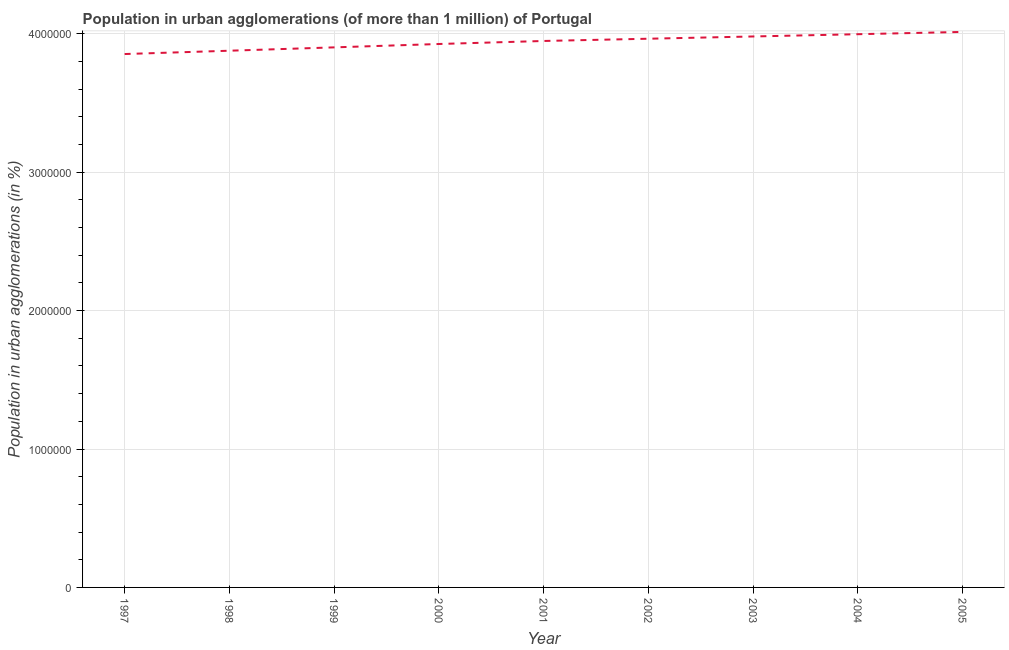What is the population in urban agglomerations in 1997?
Your response must be concise. 3.85e+06. Across all years, what is the maximum population in urban agglomerations?
Make the answer very short. 4.01e+06. Across all years, what is the minimum population in urban agglomerations?
Your answer should be very brief. 3.85e+06. What is the sum of the population in urban agglomerations?
Offer a terse response. 3.55e+07. What is the difference between the population in urban agglomerations in 2000 and 2001?
Offer a terse response. -2.19e+04. What is the average population in urban agglomerations per year?
Ensure brevity in your answer.  3.94e+06. What is the median population in urban agglomerations?
Offer a terse response. 3.95e+06. What is the ratio of the population in urban agglomerations in 2001 to that in 2003?
Give a very brief answer. 0.99. Is the difference between the population in urban agglomerations in 1997 and 2000 greater than the difference between any two years?
Give a very brief answer. No. What is the difference between the highest and the second highest population in urban agglomerations?
Provide a short and direct response. 1.64e+04. What is the difference between the highest and the lowest population in urban agglomerations?
Offer a terse response. 1.60e+05. In how many years, is the population in urban agglomerations greater than the average population in urban agglomerations taken over all years?
Provide a succinct answer. 5. Does the population in urban agglomerations monotonically increase over the years?
Your answer should be compact. Yes. How many years are there in the graph?
Ensure brevity in your answer.  9. Are the values on the major ticks of Y-axis written in scientific E-notation?
Provide a short and direct response. No. Does the graph contain any zero values?
Provide a short and direct response. No. Does the graph contain grids?
Offer a very short reply. Yes. What is the title of the graph?
Make the answer very short. Population in urban agglomerations (of more than 1 million) of Portugal. What is the label or title of the X-axis?
Your answer should be compact. Year. What is the label or title of the Y-axis?
Ensure brevity in your answer.  Population in urban agglomerations (in %). What is the Population in urban agglomerations (in %) of 1997?
Your answer should be compact. 3.85e+06. What is the Population in urban agglomerations (in %) of 1998?
Give a very brief answer. 3.88e+06. What is the Population in urban agglomerations (in %) of 1999?
Provide a succinct answer. 3.90e+06. What is the Population in urban agglomerations (in %) of 2000?
Your response must be concise. 3.93e+06. What is the Population in urban agglomerations (in %) in 2001?
Provide a succinct answer. 3.95e+06. What is the Population in urban agglomerations (in %) of 2002?
Offer a terse response. 3.96e+06. What is the Population in urban agglomerations (in %) in 2003?
Make the answer very short. 3.98e+06. What is the Population in urban agglomerations (in %) in 2004?
Offer a very short reply. 4.00e+06. What is the Population in urban agglomerations (in %) in 2005?
Offer a very short reply. 4.01e+06. What is the difference between the Population in urban agglomerations (in %) in 1997 and 1998?
Provide a succinct answer. -2.40e+04. What is the difference between the Population in urban agglomerations (in %) in 1997 and 1999?
Your response must be concise. -4.82e+04. What is the difference between the Population in urban agglomerations (in %) in 1997 and 2000?
Keep it short and to the point. -7.25e+04. What is the difference between the Population in urban agglomerations (in %) in 1997 and 2001?
Your response must be concise. -9.44e+04. What is the difference between the Population in urban agglomerations (in %) in 1997 and 2002?
Ensure brevity in your answer.  -1.11e+05. What is the difference between the Population in urban agglomerations (in %) in 1997 and 2003?
Provide a short and direct response. -1.27e+05. What is the difference between the Population in urban agglomerations (in %) in 1997 and 2004?
Provide a succinct answer. -1.43e+05. What is the difference between the Population in urban agglomerations (in %) in 1997 and 2005?
Your response must be concise. -1.60e+05. What is the difference between the Population in urban agglomerations (in %) in 1998 and 1999?
Provide a short and direct response. -2.42e+04. What is the difference between the Population in urban agglomerations (in %) in 1998 and 2000?
Provide a short and direct response. -4.85e+04. What is the difference between the Population in urban agglomerations (in %) in 1998 and 2001?
Provide a succinct answer. -7.04e+04. What is the difference between the Population in urban agglomerations (in %) in 1998 and 2002?
Offer a terse response. -8.66e+04. What is the difference between the Population in urban agglomerations (in %) in 1998 and 2003?
Your response must be concise. -1.03e+05. What is the difference between the Population in urban agglomerations (in %) in 1998 and 2004?
Provide a short and direct response. -1.19e+05. What is the difference between the Population in urban agglomerations (in %) in 1998 and 2005?
Keep it short and to the point. -1.36e+05. What is the difference between the Population in urban agglomerations (in %) in 1999 and 2000?
Provide a succinct answer. -2.44e+04. What is the difference between the Population in urban agglomerations (in %) in 1999 and 2001?
Your answer should be very brief. -4.63e+04. What is the difference between the Population in urban agglomerations (in %) in 1999 and 2002?
Make the answer very short. -6.25e+04. What is the difference between the Population in urban agglomerations (in %) in 1999 and 2003?
Offer a terse response. -7.88e+04. What is the difference between the Population in urban agglomerations (in %) in 1999 and 2004?
Offer a very short reply. -9.51e+04. What is the difference between the Population in urban agglomerations (in %) in 1999 and 2005?
Your answer should be compact. -1.12e+05. What is the difference between the Population in urban agglomerations (in %) in 2000 and 2001?
Keep it short and to the point. -2.19e+04. What is the difference between the Population in urban agglomerations (in %) in 2000 and 2002?
Ensure brevity in your answer.  -3.81e+04. What is the difference between the Population in urban agglomerations (in %) in 2000 and 2003?
Your answer should be compact. -5.44e+04. What is the difference between the Population in urban agglomerations (in %) in 2000 and 2004?
Provide a succinct answer. -7.08e+04. What is the difference between the Population in urban agglomerations (in %) in 2000 and 2005?
Give a very brief answer. -8.72e+04. What is the difference between the Population in urban agglomerations (in %) in 2001 and 2002?
Your response must be concise. -1.62e+04. What is the difference between the Population in urban agglomerations (in %) in 2001 and 2003?
Provide a succinct answer. -3.25e+04. What is the difference between the Population in urban agglomerations (in %) in 2001 and 2004?
Make the answer very short. -4.89e+04. What is the difference between the Population in urban agglomerations (in %) in 2001 and 2005?
Offer a terse response. -6.53e+04. What is the difference between the Population in urban agglomerations (in %) in 2002 and 2003?
Your answer should be compact. -1.63e+04. What is the difference between the Population in urban agglomerations (in %) in 2002 and 2004?
Offer a very short reply. -3.27e+04. What is the difference between the Population in urban agglomerations (in %) in 2002 and 2005?
Provide a short and direct response. -4.91e+04. What is the difference between the Population in urban agglomerations (in %) in 2003 and 2004?
Offer a terse response. -1.64e+04. What is the difference between the Population in urban agglomerations (in %) in 2003 and 2005?
Keep it short and to the point. -3.28e+04. What is the difference between the Population in urban agglomerations (in %) in 2004 and 2005?
Offer a very short reply. -1.64e+04. What is the ratio of the Population in urban agglomerations (in %) in 1997 to that in 1999?
Your response must be concise. 0.99. What is the ratio of the Population in urban agglomerations (in %) in 1997 to that in 2003?
Your answer should be compact. 0.97. What is the ratio of the Population in urban agglomerations (in %) in 1997 to that in 2004?
Your answer should be very brief. 0.96. What is the ratio of the Population in urban agglomerations (in %) in 1998 to that in 2002?
Your answer should be very brief. 0.98. What is the ratio of the Population in urban agglomerations (in %) in 1998 to that in 2003?
Make the answer very short. 0.97. What is the ratio of the Population in urban agglomerations (in %) in 1999 to that in 2000?
Offer a very short reply. 0.99. What is the ratio of the Population in urban agglomerations (in %) in 1999 to that in 2001?
Your response must be concise. 0.99. What is the ratio of the Population in urban agglomerations (in %) in 1999 to that in 2003?
Offer a terse response. 0.98. What is the ratio of the Population in urban agglomerations (in %) in 1999 to that in 2004?
Ensure brevity in your answer.  0.98. What is the ratio of the Population in urban agglomerations (in %) in 2000 to that in 2001?
Your response must be concise. 0.99. What is the ratio of the Population in urban agglomerations (in %) in 2000 to that in 2002?
Keep it short and to the point. 0.99. What is the ratio of the Population in urban agglomerations (in %) in 2000 to that in 2004?
Provide a succinct answer. 0.98. What is the ratio of the Population in urban agglomerations (in %) in 2000 to that in 2005?
Offer a very short reply. 0.98. What is the ratio of the Population in urban agglomerations (in %) in 2001 to that in 2002?
Make the answer very short. 1. What is the ratio of the Population in urban agglomerations (in %) in 2001 to that in 2003?
Your answer should be very brief. 0.99. What is the ratio of the Population in urban agglomerations (in %) in 2001 to that in 2004?
Provide a succinct answer. 0.99. What is the ratio of the Population in urban agglomerations (in %) in 2002 to that in 2003?
Make the answer very short. 1. What is the ratio of the Population in urban agglomerations (in %) in 2003 to that in 2005?
Provide a short and direct response. 0.99. What is the ratio of the Population in urban agglomerations (in %) in 2004 to that in 2005?
Offer a terse response. 1. 